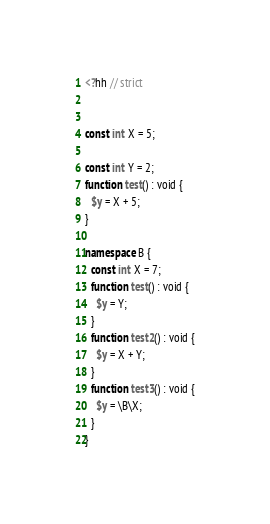<code> <loc_0><loc_0><loc_500><loc_500><_PHP_><?hh // strict


const int X = 5;

const int Y = 2;
function test() : void {
  $y = X + 5;
}

namespace B {
  const int X = 7;
  function test() : void {
    $y = Y;
  }
  function test2() : void {
    $y = X + Y;
  }
  function test3() : void {
    $y = \B\X;
  }
}
</code> 